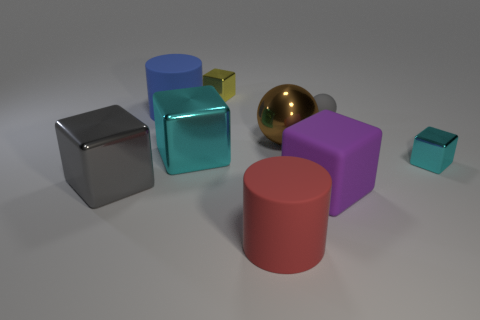What shape is the matte object that is to the left of the large purple rubber cube and behind the large red matte thing?
Your answer should be compact. Cylinder. How big is the metal sphere behind the big shiny thing to the left of the cyan cube that is to the left of the red matte cylinder?
Provide a succinct answer. Large. There is a large rubber cylinder on the right side of the big matte cylinder that is behind the red rubber thing; what color is it?
Your response must be concise. Red. There is a blue object that is the same shape as the large red matte thing; what material is it?
Offer a very short reply. Rubber. There is a large red matte thing; are there any tiny yellow metal cubes in front of it?
Give a very brief answer. No. What number of blue cylinders are there?
Give a very brief answer. 1. There is a shiny sphere that is on the left side of the tiny gray object; what number of objects are right of it?
Make the answer very short. 3. Does the tiny sphere have the same color as the big metal cube that is to the left of the large cyan metal thing?
Give a very brief answer. Yes. How many other metal things have the same shape as the yellow thing?
Your answer should be compact. 3. There is a small cube behind the brown metal thing; what is it made of?
Make the answer very short. Metal. 